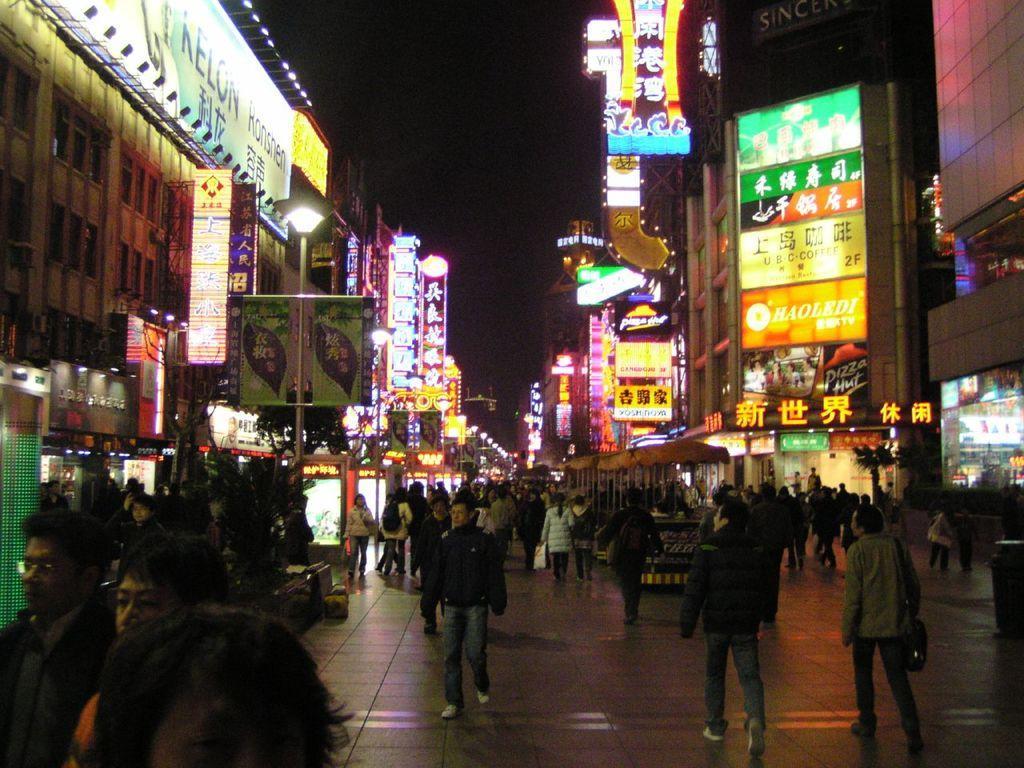Could you give a brief overview of what you see in this image? In this image, we can see some people walking, there are some buildings, we can see some shops and there are some banners and we can see the lights. 